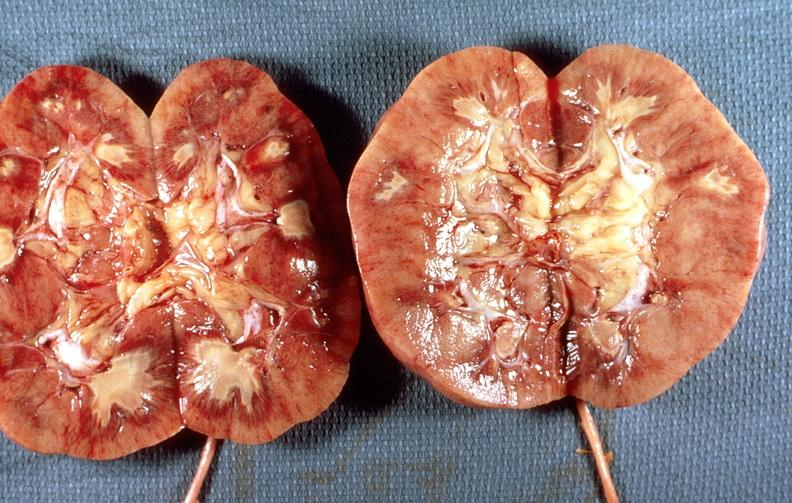does pierre robin sndrome show renal papillary necrosis, diabetes mellitus dm?
Answer the question using a single word or phrase. No 